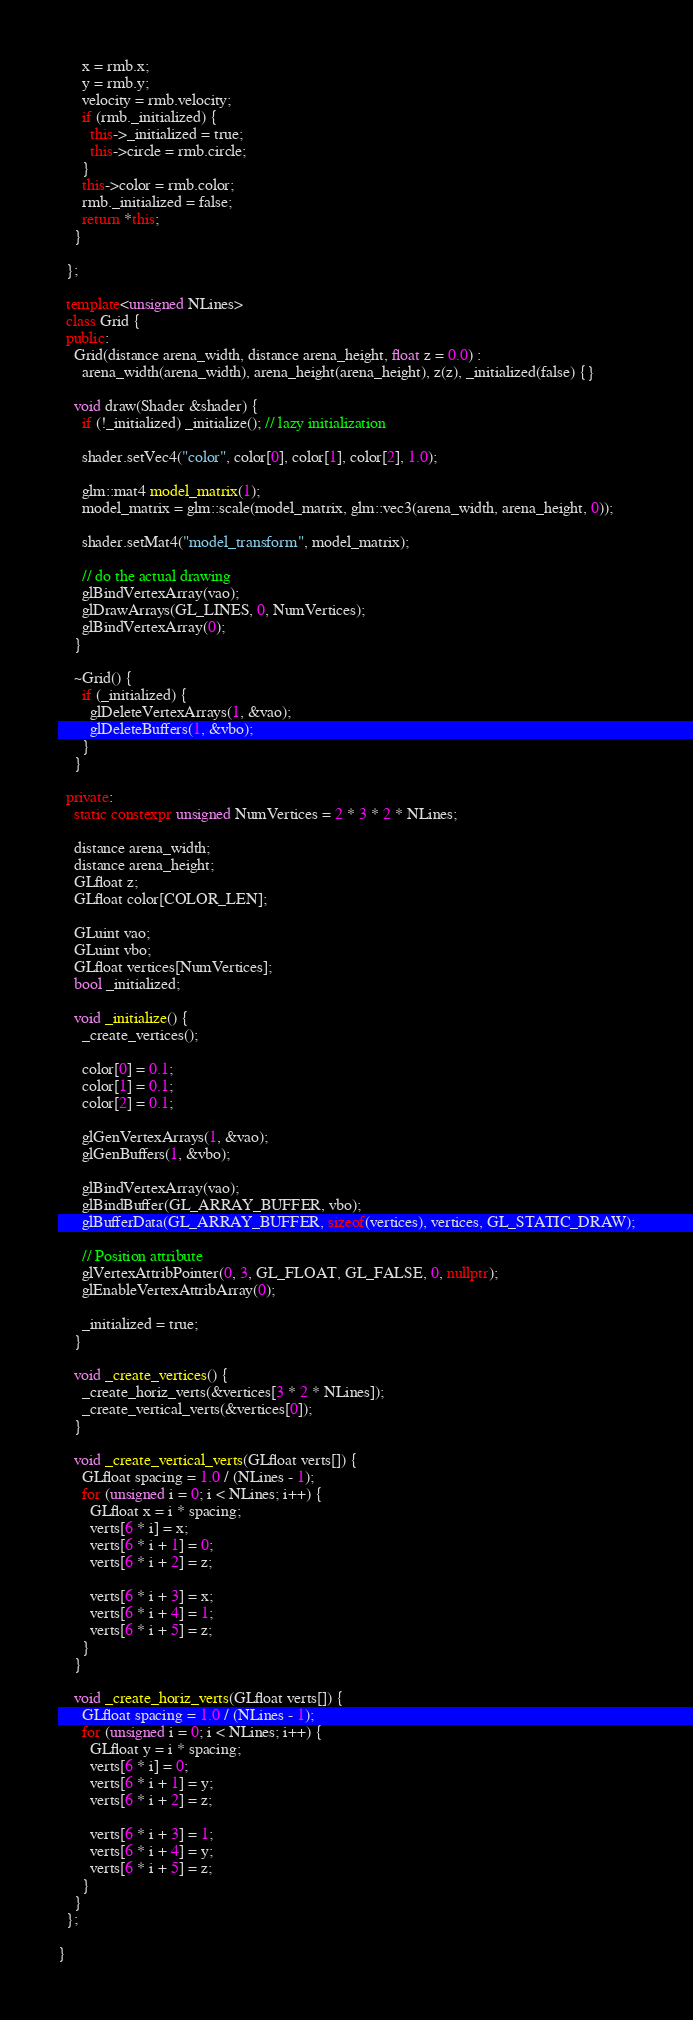Convert code to text. <code><loc_0><loc_0><loc_500><loc_500><_C++_>      x = rmb.x;
      y = rmb.y;
      velocity = rmb.velocity;
      if (rmb._initialized) {
        this->_initialized = true;
        this->circle = rmb.circle;
      }
      this->color = rmb.color;
      rmb._initialized = false;
      return *this;
    }

  };

  template<unsigned NLines>
  class Grid {
  public:
    Grid(distance arena_width, distance arena_height, float z = 0.0) :
      arena_width(arena_width), arena_height(arena_height), z(z), _initialized(false) {}

    void draw(Shader &shader) {
      if (!_initialized) _initialize(); // lazy initialization

      shader.setVec4("color", color[0], color[1], color[2], 1.0);

      glm::mat4 model_matrix(1);
      model_matrix = glm::scale(model_matrix, glm::vec3(arena_width, arena_height, 0));

      shader.setMat4("model_transform", model_matrix);

      // do the actual drawing
      glBindVertexArray(vao);
      glDrawArrays(GL_LINES, 0, NumVertices);
      glBindVertexArray(0);
    }

    ~Grid() {
      if (_initialized) {
        glDeleteVertexArrays(1, &vao);
        glDeleteBuffers(1, &vbo);
      }
    }

  private:
    static constexpr unsigned NumVertices = 2 * 3 * 2 * NLines;

    distance arena_width;
    distance arena_height;
    GLfloat z;
    GLfloat color[COLOR_LEN];

    GLuint vao;
    GLuint vbo;
    GLfloat vertices[NumVertices];
    bool _initialized;

    void _initialize() {
      _create_vertices();

      color[0] = 0.1;
      color[1] = 0.1;
      color[2] = 0.1;

      glGenVertexArrays(1, &vao);
      glGenBuffers(1, &vbo);

      glBindVertexArray(vao);
      glBindBuffer(GL_ARRAY_BUFFER, vbo);
      glBufferData(GL_ARRAY_BUFFER, sizeof(vertices), vertices, GL_STATIC_DRAW);

      // Position attribute
      glVertexAttribPointer(0, 3, GL_FLOAT, GL_FALSE, 0, nullptr);
      glEnableVertexAttribArray(0);

      _initialized = true;
    }

    void _create_vertices() {
      _create_horiz_verts(&vertices[3 * 2 * NLines]);
      _create_vertical_verts(&vertices[0]);
    }

    void _create_vertical_verts(GLfloat verts[]) {
      GLfloat spacing = 1.0 / (NLines - 1);
      for (unsigned i = 0; i < NLines; i++) {
        GLfloat x = i * spacing;
        verts[6 * i] = x;
        verts[6 * i + 1] = 0;
        verts[6 * i + 2] = z;

        verts[6 * i + 3] = x;
        verts[6 * i + 4] = 1;
        verts[6 * i + 5] = z;
      }
    }

    void _create_horiz_verts(GLfloat verts[]) {
      GLfloat spacing = 1.0 / (NLines - 1);
      for (unsigned i = 0; i < NLines; i++) {
        GLfloat y = i * spacing;
        verts[6 * i] = 0;
        verts[6 * i + 1] = y;
        verts[6 * i + 2] = z;

        verts[6 * i + 3] = 1;
        verts[6 * i + 4] = y;
        verts[6 * i + 5] = z;
      }
    }
  };

}
</code> 